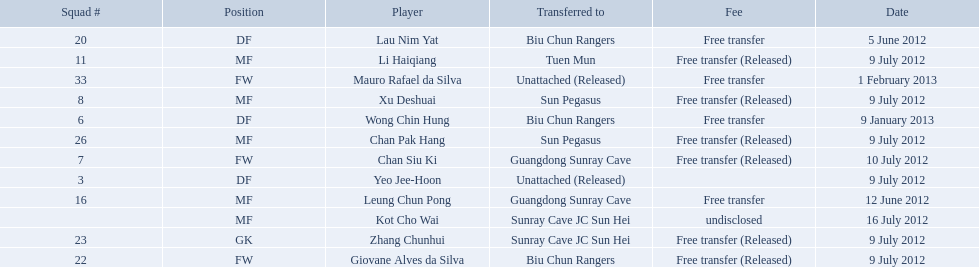Which players are listed? Lau Nim Yat, Leung Chun Pong, Yeo Jee-Hoon, Xu Deshuai, Li Haiqiang, Giovane Alves da Silva, Zhang Chunhui, Chan Pak Hang, Chan Siu Ki, Kot Cho Wai, Wong Chin Hung, Mauro Rafael da Silva. Which dates were players transferred to the biu chun rangers? 5 June 2012, 9 July 2012, 9 January 2013. Of those which is the date for wong chin hung? 9 January 2013. 